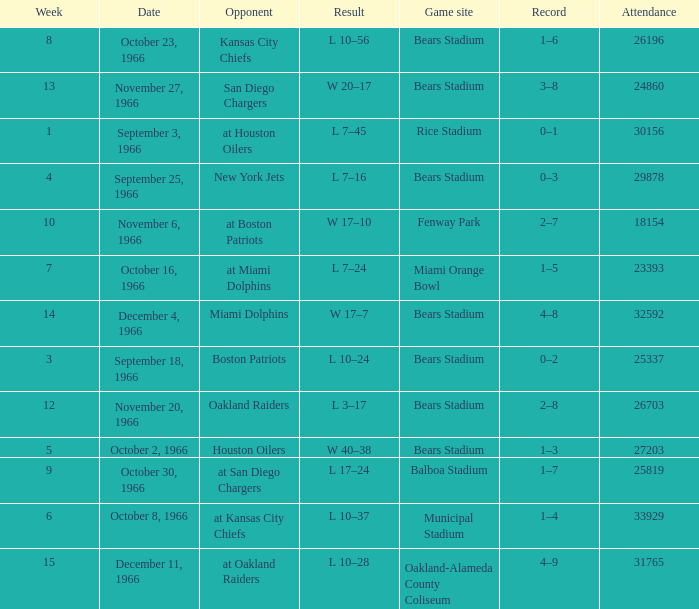How many results are listed for week 13? 1.0. 